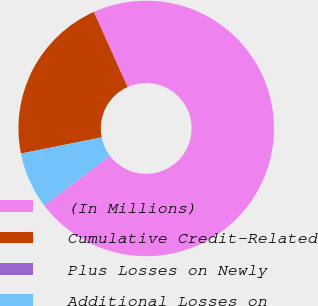Convert chart. <chart><loc_0><loc_0><loc_500><loc_500><pie_chart><fcel>(In Millions)<fcel>Cumulative Credit-Related<fcel>Plus Losses on Newly<fcel>Additional Losses on<nl><fcel>71.42%<fcel>21.43%<fcel>0.0%<fcel>7.15%<nl></chart> 